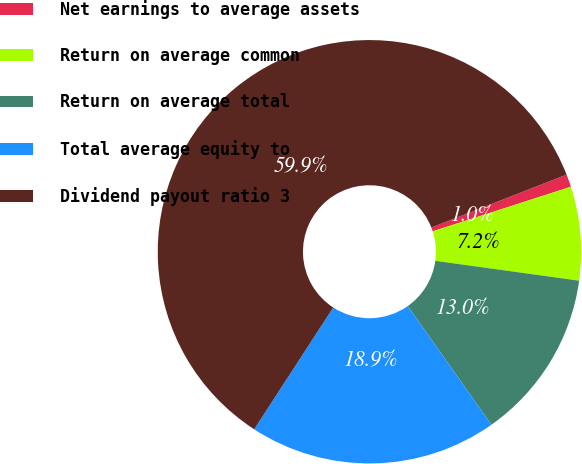Convert chart. <chart><loc_0><loc_0><loc_500><loc_500><pie_chart><fcel>Net earnings to average assets<fcel>Return on average common<fcel>Return on average total<fcel>Total average equity to<fcel>Dividend payout ratio 3<nl><fcel>0.97%<fcel>7.15%<fcel>13.04%<fcel>18.94%<fcel>59.9%<nl></chart> 